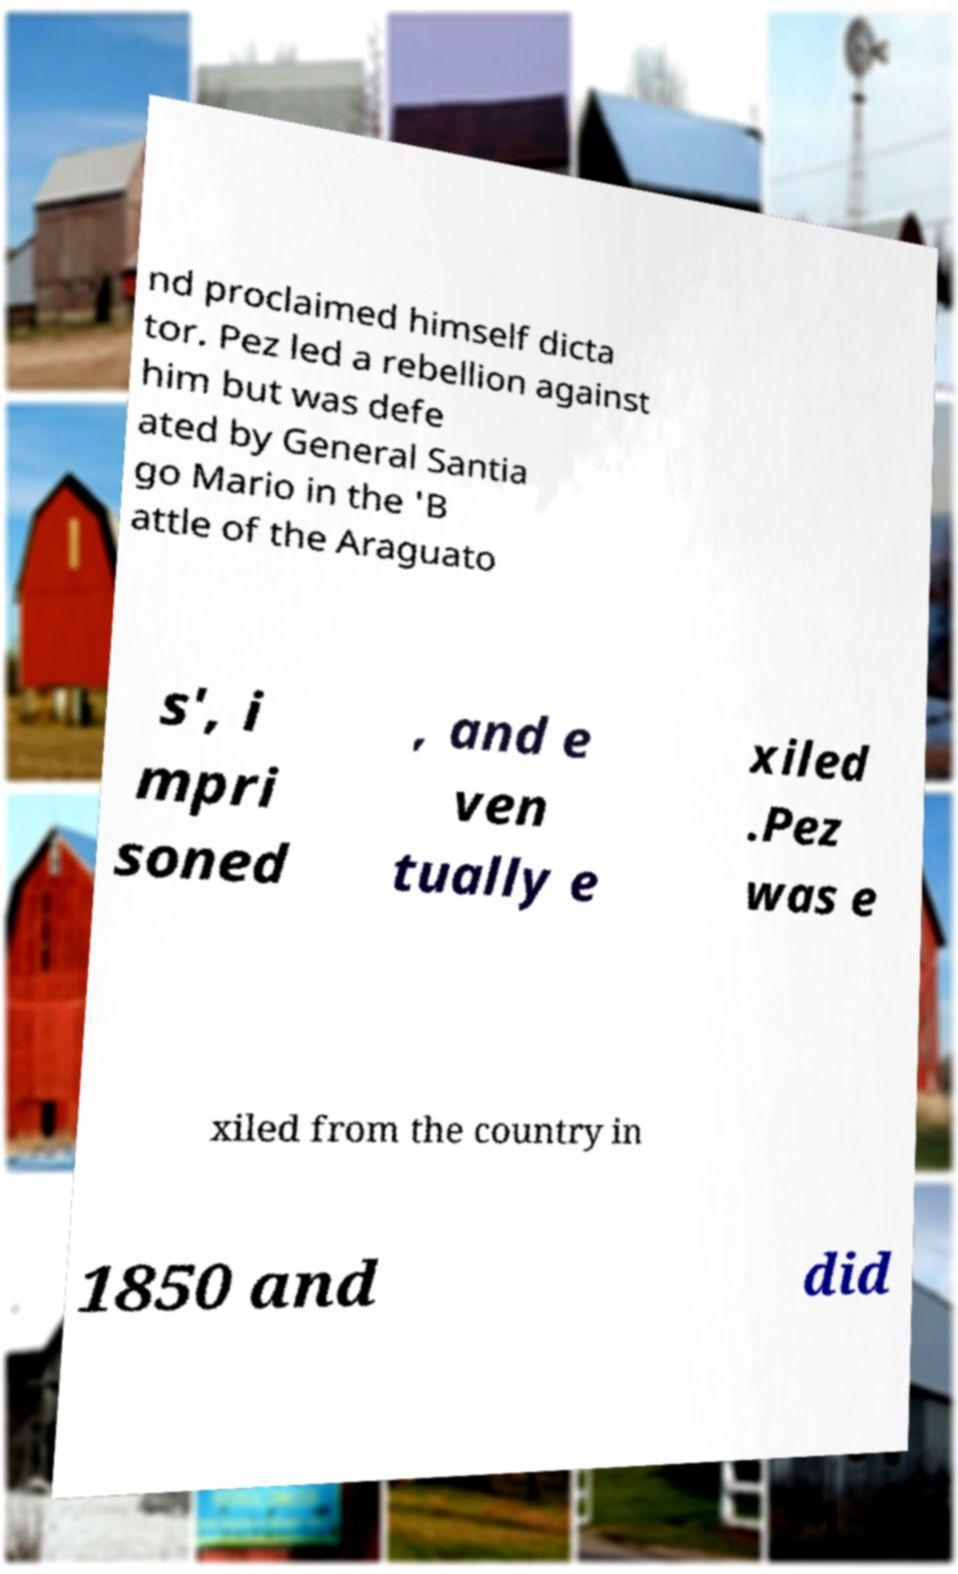I need the written content from this picture converted into text. Can you do that? nd proclaimed himself dicta tor. Pez led a rebellion against him but was defe ated by General Santia go Mario in the 'B attle of the Araguato s', i mpri soned , and e ven tually e xiled .Pez was e xiled from the country in 1850 and did 